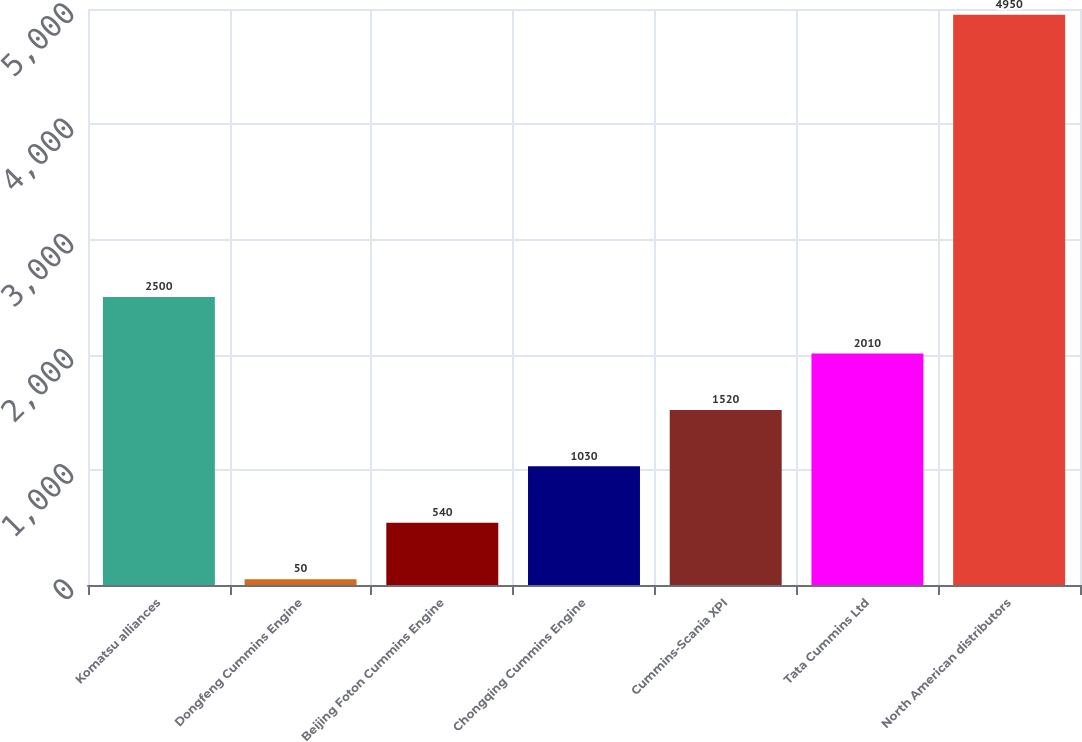Convert chart. <chart><loc_0><loc_0><loc_500><loc_500><bar_chart><fcel>Komatsu alliances<fcel>Dongfeng Cummins Engine<fcel>Beijing Foton Cummins Engine<fcel>Chongqing Cummins Engine<fcel>Cummins-Scania XPI<fcel>Tata Cummins Ltd<fcel>North American distributors<nl><fcel>2500<fcel>50<fcel>540<fcel>1030<fcel>1520<fcel>2010<fcel>4950<nl></chart> 